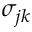Convert formula to latex. <formula><loc_0><loc_0><loc_500><loc_500>\sigma _ { j k }</formula> 